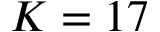<formula> <loc_0><loc_0><loc_500><loc_500>K = 1 7</formula> 